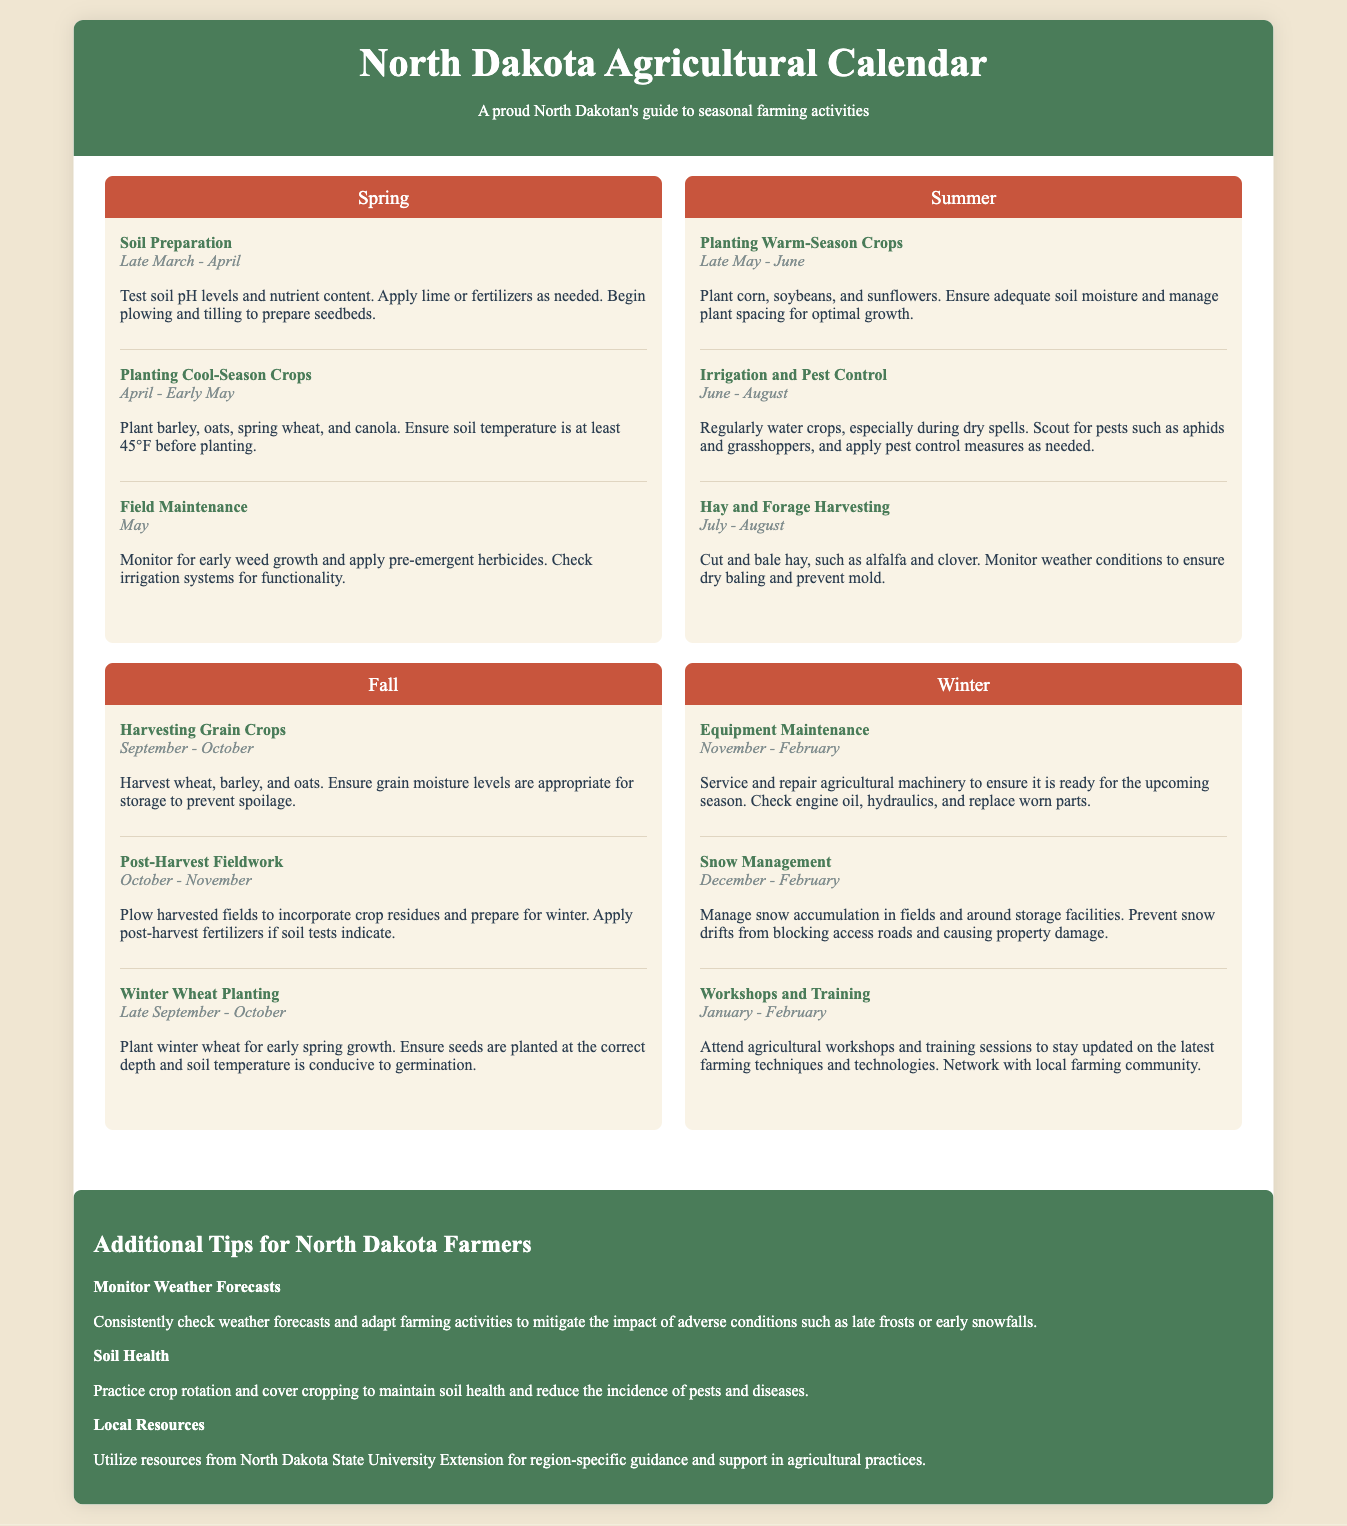What is the planting date for cool-season crops? The planting date for cool-season crops is specified as April to early May in the document.
Answer: April - Early May When should winter wheat be planted? The document states that winter wheat should be planted from late September to October.
Answer: Late September - October What activity is suggested for November to February? The document mentions equipment maintenance as the activity for November to February.
Answer: Equipment Maintenance During which season is hay and forage harvesting conducted? The document lists July to August as the time for hay and forage harvesting, indicating the summer season.
Answer: Summer What is one tip for North Dakota farmers mentioned in the document? The document provides several tips, one of which is to monitor weather forecasts for farming activities.
Answer: Monitor Weather Forecasts How long does the irrigation and pest control activity last? The duration for irrigation and pest control is indicated as June to August in the document.
Answer: June - August What are the months for post-harvest fieldwork? The document states that post-harvest fieldwork occurs from October to November.
Answer: October - November Which crops should be planted in late May to June? The document lists corn, soybeans, and sunflowers as crops to be planted during this period.
Answer: Corn, soybeans, and sunflowers 